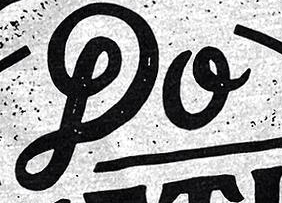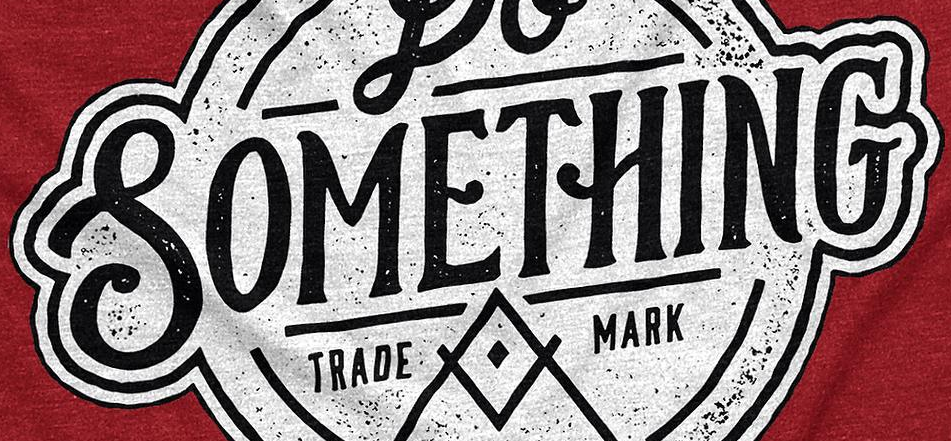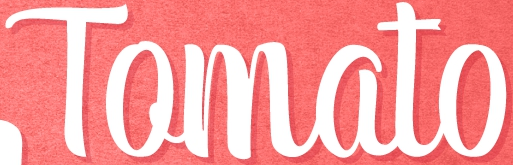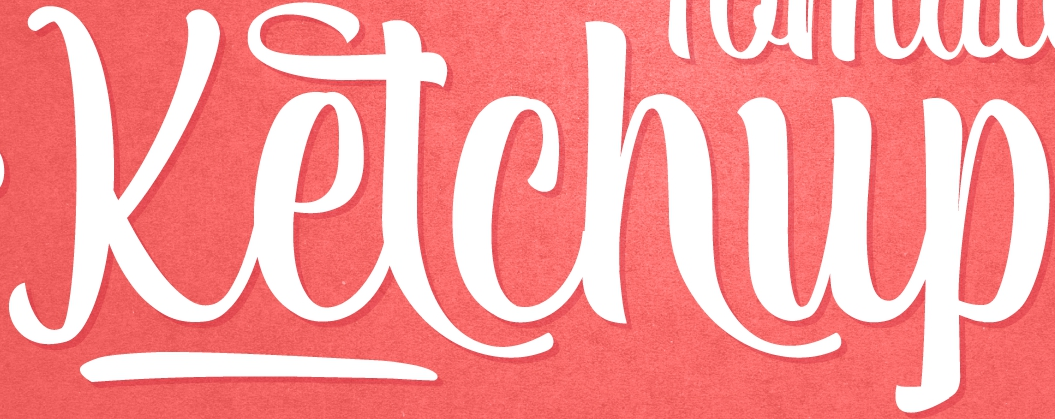Read the text from these images in sequence, separated by a semicolon. DO; SOMETHING; Tomato; Ketchup 